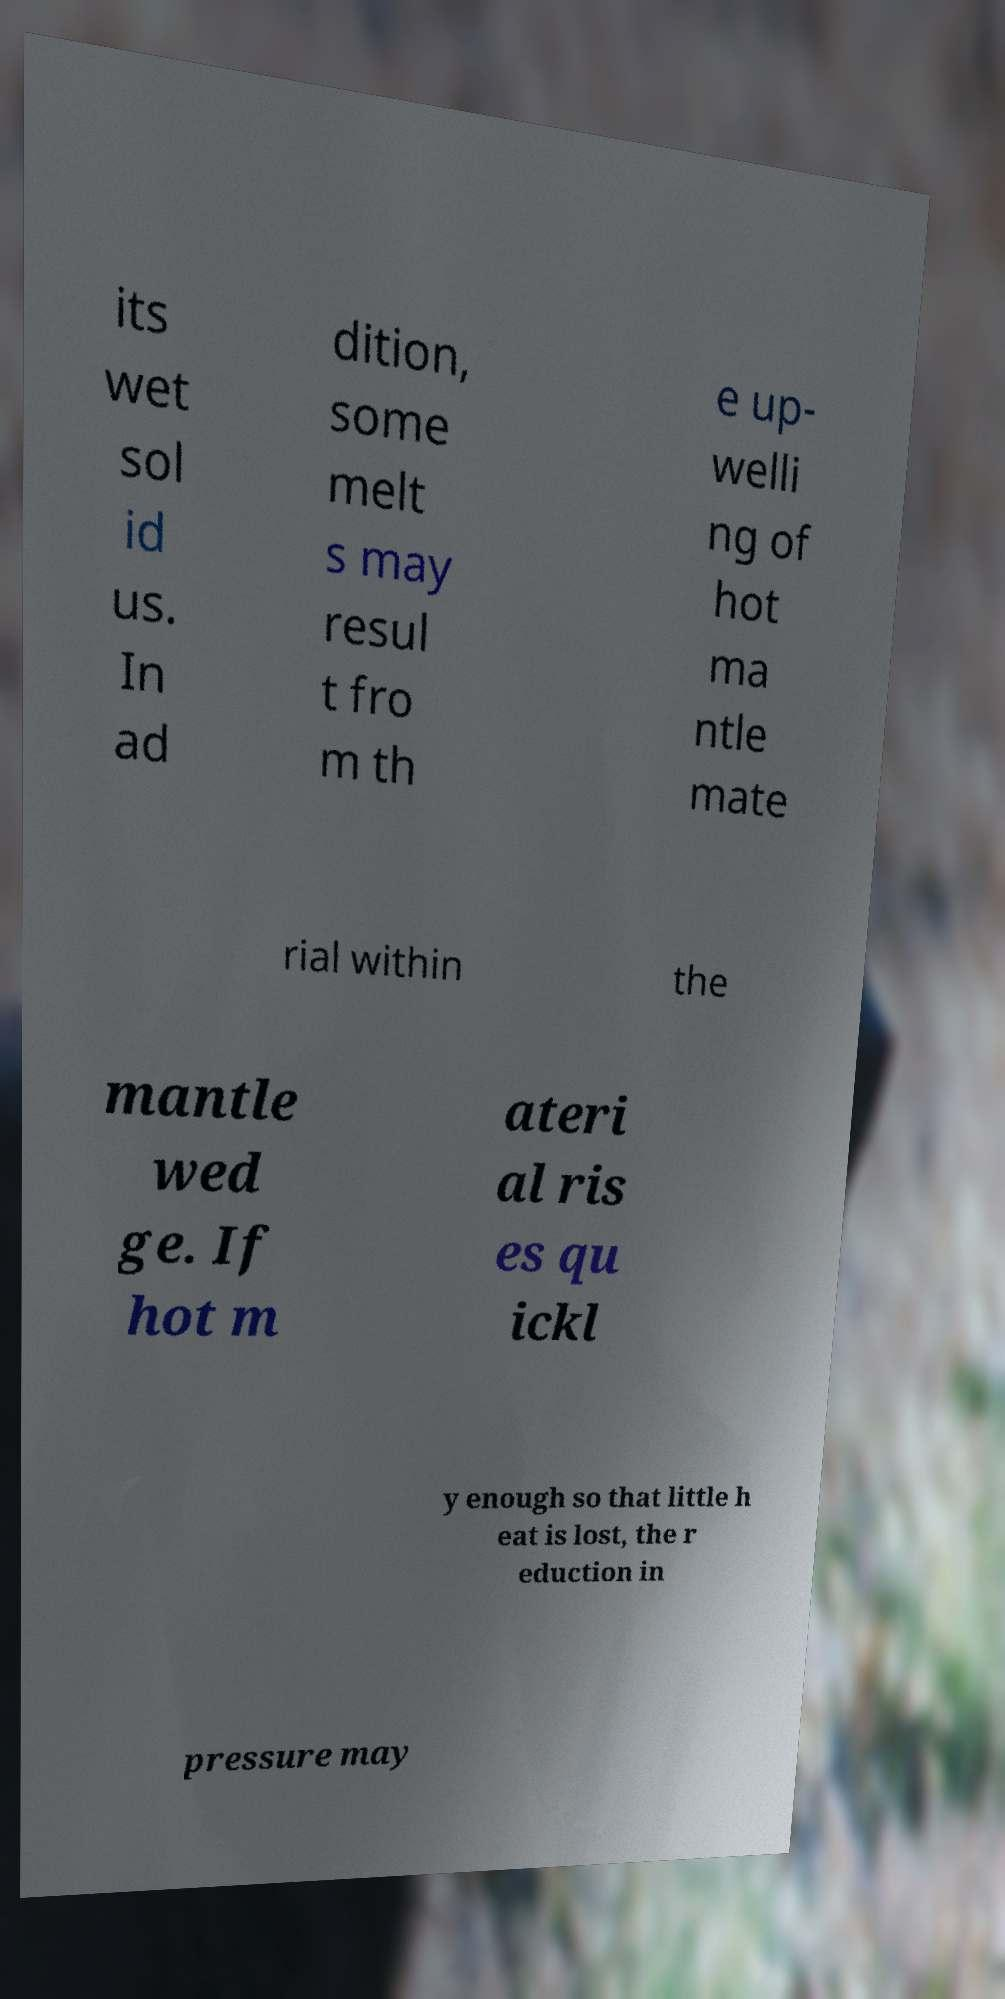Can you read and provide the text displayed in the image?This photo seems to have some interesting text. Can you extract and type it out for me? its wet sol id us. In ad dition, some melt s may resul t fro m th e up- welli ng of hot ma ntle mate rial within the mantle wed ge. If hot m ateri al ris es qu ickl y enough so that little h eat is lost, the r eduction in pressure may 